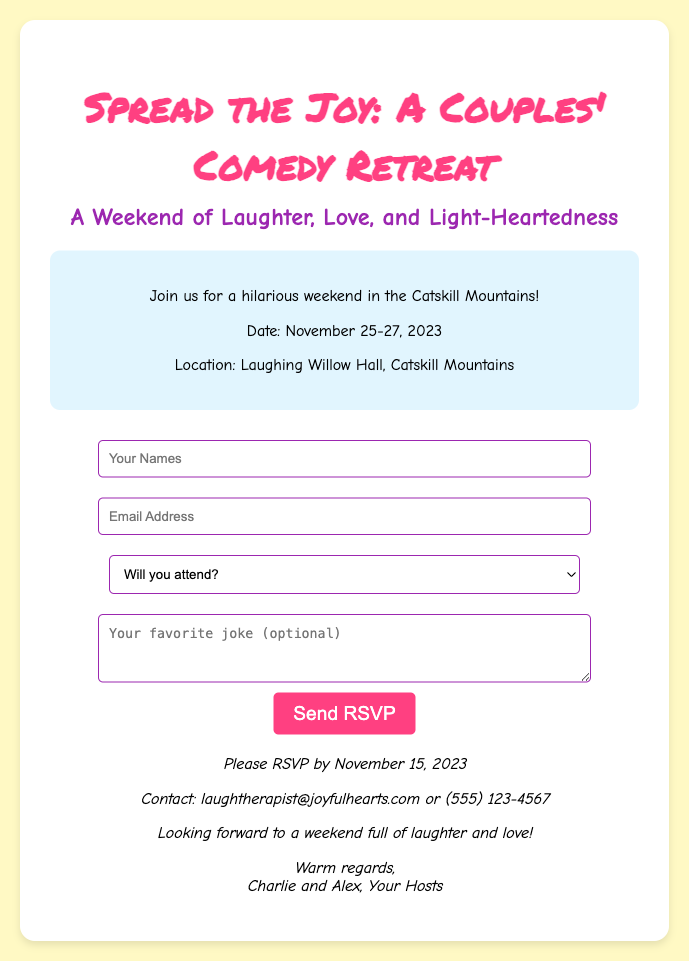What is the name of the retreat? The name of the retreat is mentioned prominently in the title at the top of the document.
Answer: Couples' Comedy Retreat What are the dates of the retreat? The dates are specified in one of the paragraphs within the details section.
Answer: November 25-27, 2023 Where is the retreat located? The location is clearly stated in the details section of the document.
Answer: Laughing Willow Hall, Catskill Mountains What is the RSVP deadline? The deadline is mentioned in the footer section of the document.
Answer: November 15, 2023 Who are the hosts of the retreat? The hosts' names are provided at the end of the document.
Answer: Charlie and Alex What is required to RSVP? The required information to RSVP is indicated in the form section of the document.
Answer: Your Names, Email Address, Attendance Confirmation What additional contribution can attendees make? The optional information that can be shared is specified in the form.
Answer: Favorite joke What is the contact email for the event? This information is provided in the footer of the document.
Answer: laughtherapist@joyfulhearts.com What theme does the retreat focus on? The theme is conveyed in the title and introductory paragraph of the document.
Answer: Laughter and Love 